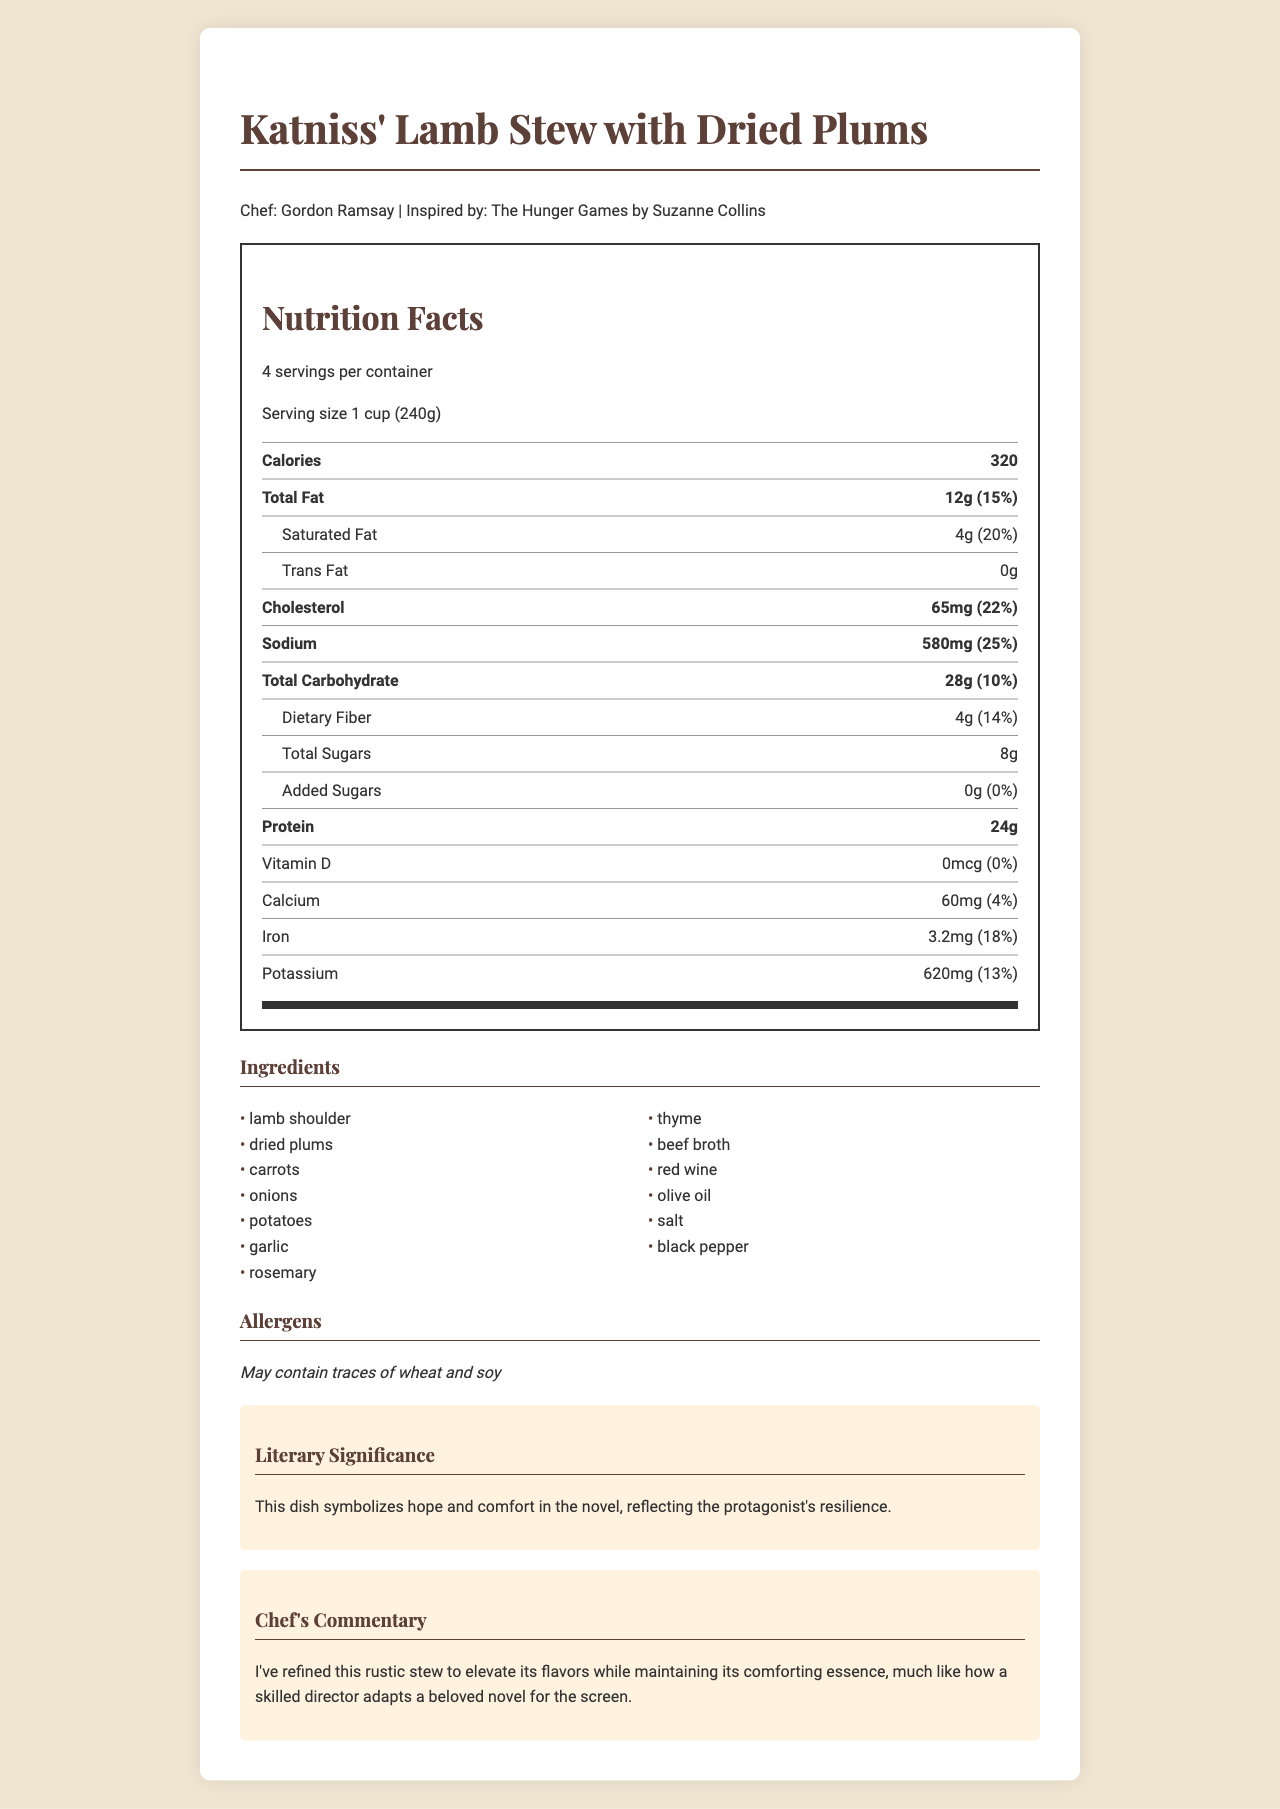What is the name of the dish? The name of the dish is listed at the top of the document.
Answer: Katniss' Lamb Stew with Dried Plums Who is the celebrity chef that created this dish? The chef's name is mentioned right under the dish's name at the beginning of the document.
Answer: Gordon Ramsay What serving size is given for this dish? The serving size is specified in the nutrition facts section.
Answer: 1 cup (240g) How many calories are in one serving of this dish? The number of calories per serving is listed in the nutrition facts section under the calories row.
Answer: 320 List two main ingredients used in this dish. The ingredients section lists lamb shoulder and dried plums among other ingredients.
Answer: Lamb shoulder, dried plums How much protein is in one serving of this dish? The amount of protein per serving is noted in the nutrition facts section.
Answer: 24g Which ingredient is NOT listed in the ingredients section? 
A. Thyme
B. Asparagus
C. Olive oil
D. Garlic The ingredients section lists thyme, olive oil, and garlic, but not asparagus.
Answer: B. Asparagus What is the total fat content in one serving? 
I. 10g
II. 12g
III. 15g The total fat amount of 12g per serving is stated in the nutrition facts section.
Answer: II. 12g Can you tell what book inspired this recipe? The recipe was inspired by "The Hunger Games by Suzanne Collins" as stated at the start of the document.
Answer: Yes Does this dish contain added sugars? The nutrition facts state that the amount of added sugars is 0g.
Answer: No Summarize the overall purpose and content of this document. The document is a comprehensive presentation of a signature dish, detailing its nutritional facts, ingredients, allergens, and the inspiration behind it.
Answer: The document provides the nutritional breakdown and ingredients of a dish called "Katniss' Lamb Stew with Dried Plums" created by chef Gordon Ramsay and inspired by "The Hunger Games". It includes the preparation method, the literary significance of the dish, and the chef’s commentary on it. How long is this dish slow-cooked for? The preparation method section specifies that the dish is slow-cooked for 4 hours.
Answer: 4 hours What literary significance is attached to this dish? The literary significance section explains what the dish represents in the novel.
Answer: It symbolizes hope and comfort in the novel, reflecting the protagonist's resilience. What is the daily value percentage of sodium in this dish? The sodium content has a daily value percentage of 25% as noted in the nutrition facts section.
Answer: 25% What are the allergens listed for this dish? The allergens section specifies that the dish may contain traces of wheat and soy.
Answer: May contain traces of wheat and soy What is the chef's commentary on this dish? The chef's commentary section provides this statement.
Answer: "I've refined this rustic stew to elevate its flavors while maintaining its comforting essence, much like how a skilled director adapts a beloved novel for the screen." What is the amount of calcium in one serving? The calcium content is listed as 60mg per serving in the nutrition facts section.
Answer: 60mg What are the health benefits of this dish? The document does not mention specific health benefits, so the answer cannot be determined based on the provided information.
Answer: Not enough information 